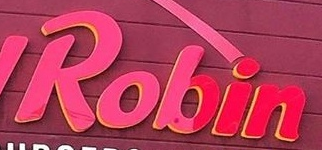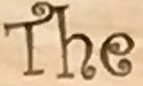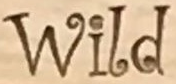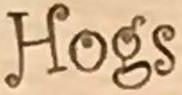What text appears in these images from left to right, separated by a semicolon? Robin; The; Wild; Hogs 